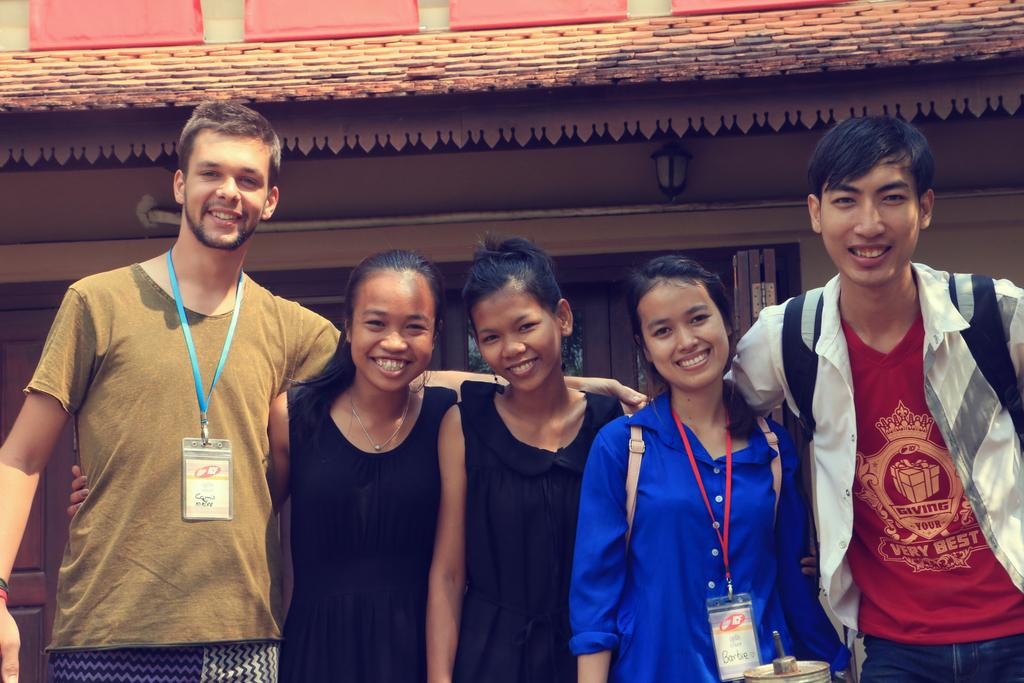How many people are present in the image? There are five persons standing in the image. What can be seen in the background of the image? There is a building visible in the background of the image. How long does it take for the pump to wash the minute in the image? There is no pump or minute present in the image, so this question cannot be answered. 